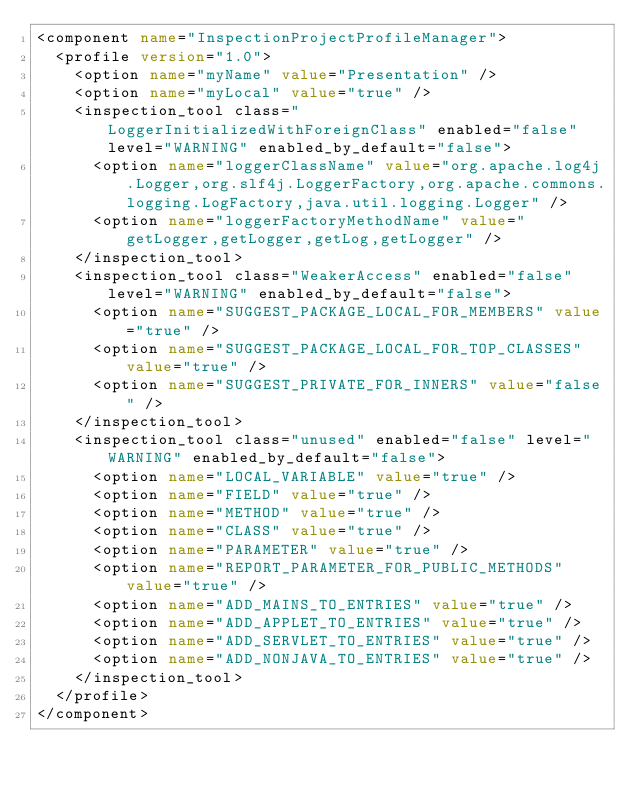Convert code to text. <code><loc_0><loc_0><loc_500><loc_500><_XML_><component name="InspectionProjectProfileManager">
  <profile version="1.0">
    <option name="myName" value="Presentation" />
    <option name="myLocal" value="true" />
    <inspection_tool class="LoggerInitializedWithForeignClass" enabled="false" level="WARNING" enabled_by_default="false">
      <option name="loggerClassName" value="org.apache.log4j.Logger,org.slf4j.LoggerFactory,org.apache.commons.logging.LogFactory,java.util.logging.Logger" />
      <option name="loggerFactoryMethodName" value="getLogger,getLogger,getLog,getLogger" />
    </inspection_tool>
    <inspection_tool class="WeakerAccess" enabled="false" level="WARNING" enabled_by_default="false">
      <option name="SUGGEST_PACKAGE_LOCAL_FOR_MEMBERS" value="true" />
      <option name="SUGGEST_PACKAGE_LOCAL_FOR_TOP_CLASSES" value="true" />
      <option name="SUGGEST_PRIVATE_FOR_INNERS" value="false" />
    </inspection_tool>
    <inspection_tool class="unused" enabled="false" level="WARNING" enabled_by_default="false">
      <option name="LOCAL_VARIABLE" value="true" />
      <option name="FIELD" value="true" />
      <option name="METHOD" value="true" />
      <option name="CLASS" value="true" />
      <option name="PARAMETER" value="true" />
      <option name="REPORT_PARAMETER_FOR_PUBLIC_METHODS" value="true" />
      <option name="ADD_MAINS_TO_ENTRIES" value="true" />
      <option name="ADD_APPLET_TO_ENTRIES" value="true" />
      <option name="ADD_SERVLET_TO_ENTRIES" value="true" />
      <option name="ADD_NONJAVA_TO_ENTRIES" value="true" />
    </inspection_tool>
  </profile>
</component></code> 